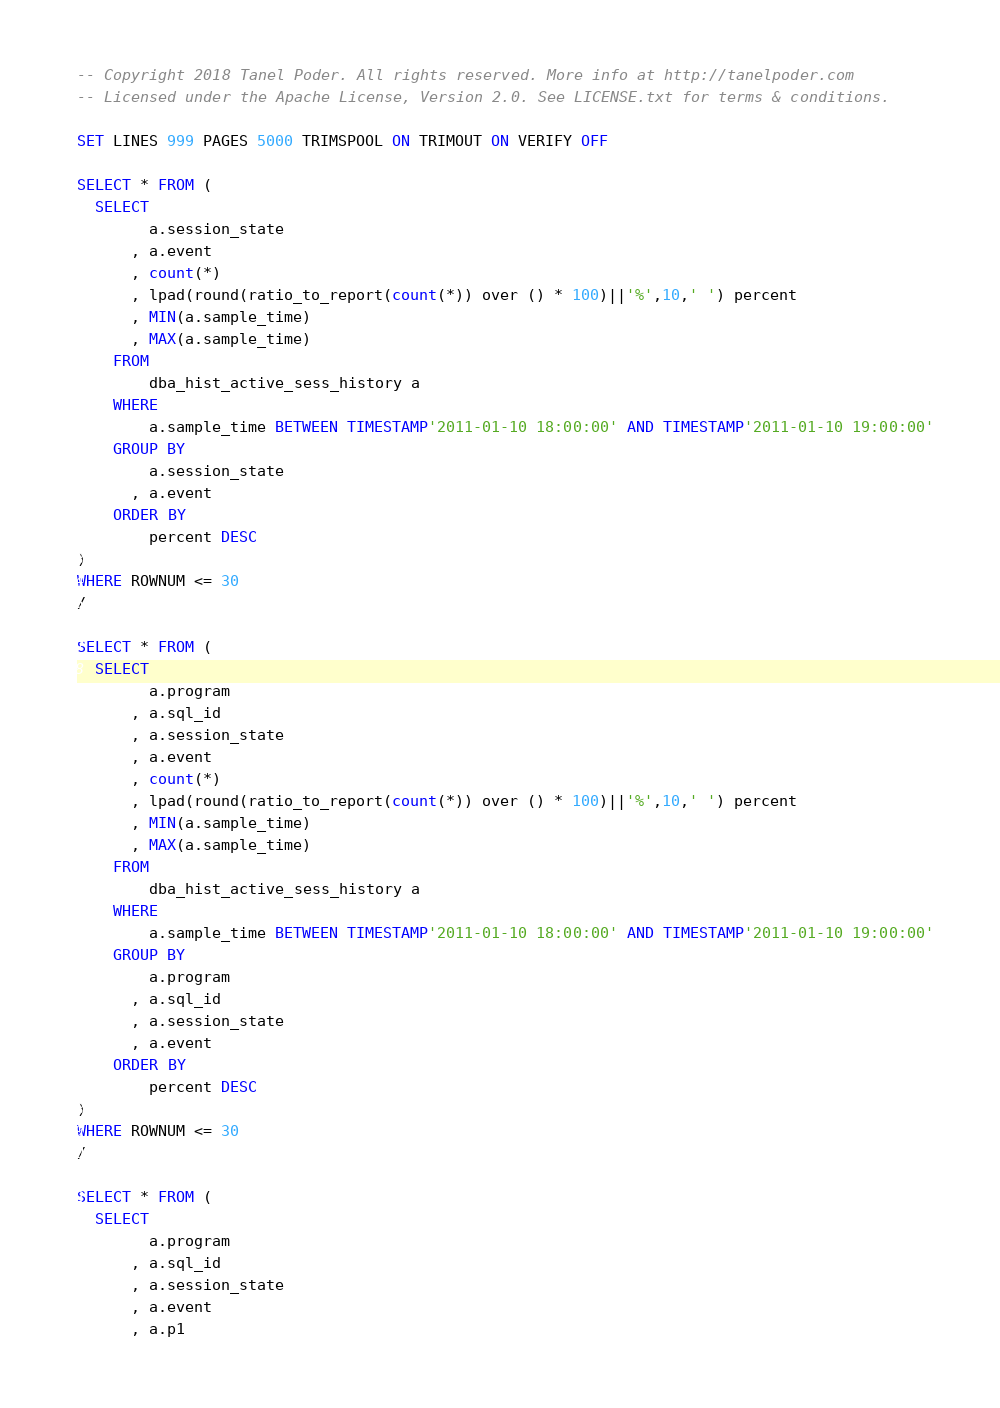<code> <loc_0><loc_0><loc_500><loc_500><_SQL_>-- Copyright 2018 Tanel Poder. All rights reserved. More info at http://tanelpoder.com
-- Licensed under the Apache License, Version 2.0. See LICENSE.txt for terms & conditions.

SET LINES 999 PAGES 5000 TRIMSPOOL ON TRIMOUT ON VERIFY OFF

SELECT * FROM (
  SELECT 
        a.session_state
      , a.event
      , count(*)
      , lpad(round(ratio_to_report(count(*)) over () * 100)||'%',10,' ') percent
      , MIN(a.sample_time)
      , MAX(a.sample_time)
    FROM
        dba_hist_active_sess_history a
    WHERE
        a.sample_time BETWEEN TIMESTAMP'2011-01-10 18:00:00' AND TIMESTAMP'2011-01-10 19:00:00'
    GROUP BY
        a.session_state
      , a.event
    ORDER BY
        percent DESC
)
WHERE ROWNUM <= 30
/

SELECT * FROM (
  SELECT 
        a.program
      , a.sql_id
      , a.session_state
      , a.event
      , count(*)
      , lpad(round(ratio_to_report(count(*)) over () * 100)||'%',10,' ') percent
      , MIN(a.sample_time)
      , MAX(a.sample_time)
    FROM
        dba_hist_active_sess_history a
    WHERE
        a.sample_time BETWEEN TIMESTAMP'2011-01-10 18:00:00' AND TIMESTAMP'2011-01-10 19:00:00'
    GROUP BY
        a.program
      , a.sql_id
      , a.session_state
      , a.event
    ORDER BY
        percent DESC
)
WHERE ROWNUM <= 30
/

SELECT * FROM (
  SELECT
        a.program
      , a.sql_id
      , a.session_state
      , a.event
      , a.p1</code> 